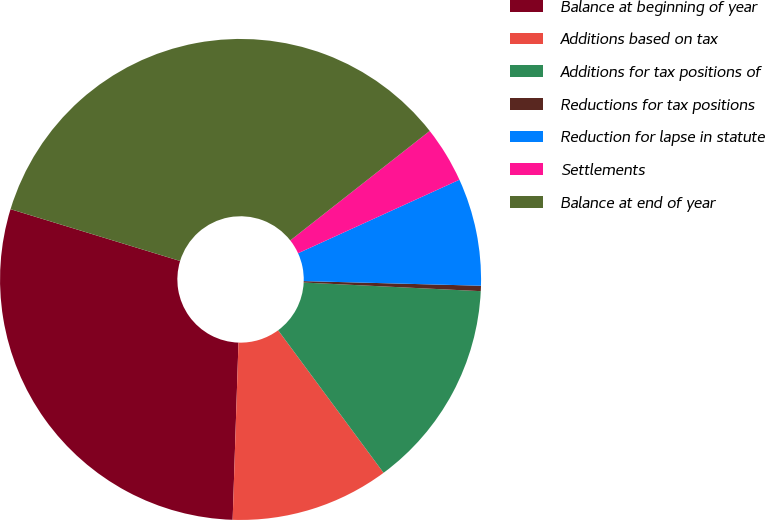Convert chart. <chart><loc_0><loc_0><loc_500><loc_500><pie_chart><fcel>Balance at beginning of year<fcel>Additions based on tax<fcel>Additions for tax positions of<fcel>Reductions for tax positions<fcel>Reduction for lapse in statute<fcel>Settlements<fcel>Balance at end of year<nl><fcel>29.2%<fcel>10.66%<fcel>14.09%<fcel>0.36%<fcel>7.22%<fcel>3.79%<fcel>34.69%<nl></chart> 